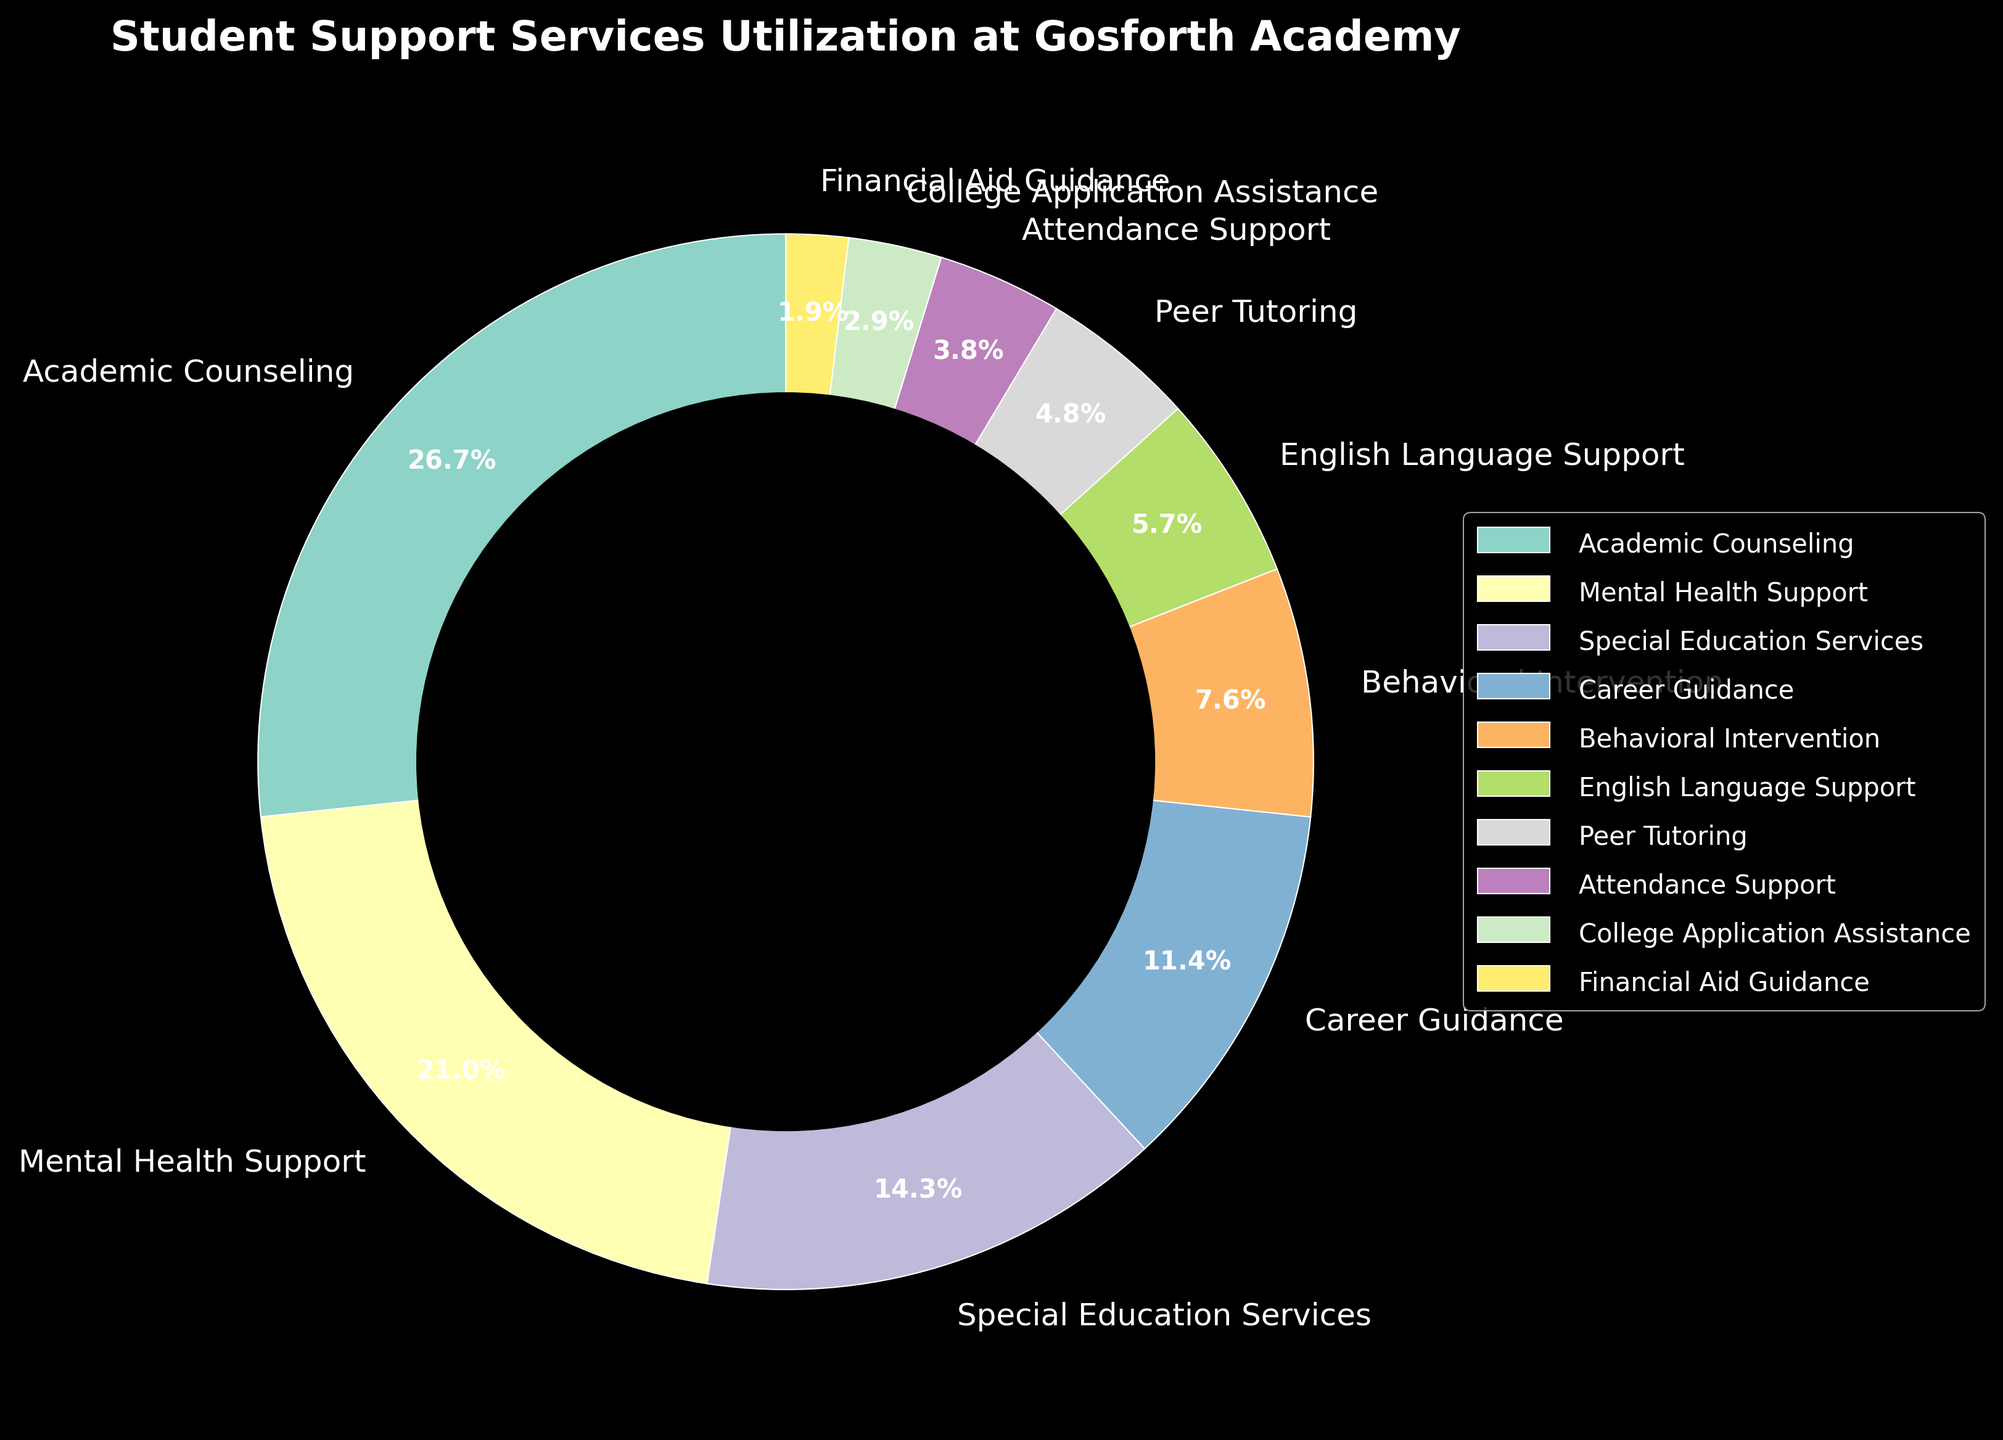Which service has the highest utilization percentage? By examining the pie chart, we can see that the largest segment is for Academic Counseling. The percentage is directly labeled on the segment.
Answer: Academic Counseling Which service has a higher utilization percentage: Mental Health Support or Career Guidance? Comparing the two segments visually, Mental Health Support appears larger with a percentage label of 22%, whereas Career Guidance has a smaller segment with a percentage label of 12%.
Answer: Mental Health Support What is the combined percentage of Special Education Services and Behavioral Intervention? To find the combined percentage, we add the percentages of Special Education Services (15%) and Behavioral Intervention (8%). The result is 15% + 8% = 23%.
Answer: 23% How does the utilization of English Language Support compare to Peer Tutoring? By comparing the respective segments, English Language Support is slightly larger with a percentage of 6%, while Peer Tutoring has a percentage of 5%.
Answer: English Language Support Which three services have the lowest utilization percentages, and what are their values? The three smallest segments in the pie chart represent College Application Assistance, Financial Aid Guidance, and Attendance Support with percentages of 3%, 2%, and 4% respectively. These can be identified by their small visual representation and direct labels.
Answer: College Application Assistance (3%), Financial Aid Guidance (2%), Attendance Support (4%) What is the difference in utilization percentage between Academic Counseling and Mental Health Support? The percentage for Academic Counseling is 28%, and for Mental Health Support, it is 22%. The difference is calculated by subtracting the smaller percentage from the larger one: 28% - 22% = 6%.
Answer: 6% How many services have a utilization percentage of 10% or higher? By examining the pie chart and reading the percentage labels, services with utilization percentages 10% or higher are Academic Counseling (28%), Mental Health Support (22%), Special Education Services (15%), and Career Guidance (12%). This gives a total of four services.
Answer: 4 What percentage of the total does Financial Aid Guidance represent? By reading the labeled percentage on the Financial Aid Guidance segment, we can see it represents 2% of the total.
Answer: 2% If we combine all services under 10%, what is their total utilization percentage? Services under 10% include Behavioral Intervention (8%), English Language Support (6%), Peer Tutoring (5%), Attendance Support (4%), College Application Assistance (3%), and Financial Aid Guidance (2%). Adding these, the total is 8% + 6% + 5% + 4% + 3% + 2% = 28%.
Answer: 28% What is the visual indication of the data representing the subject of the plot? The plot features a title "Student Support Services Utilization at Gosforth Academy," providing a clear visual indicator of the data subject.
Answer: Title of plot 